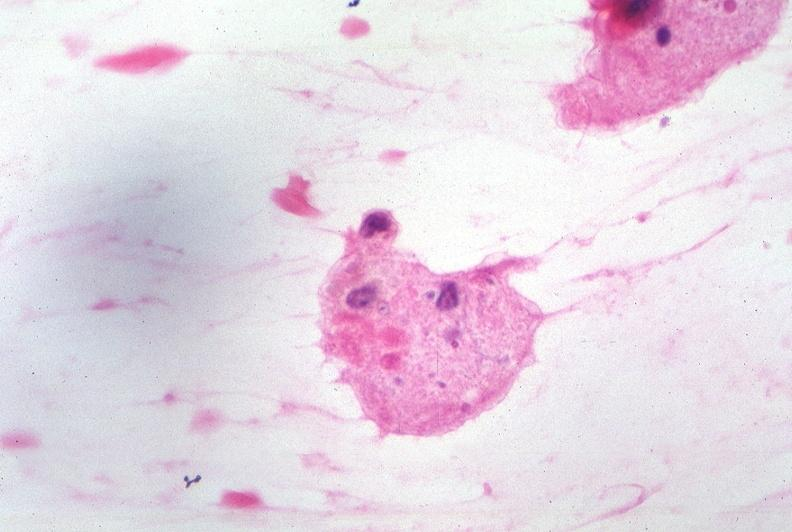s nervous present?
Answer the question using a single word or phrase. Yes 